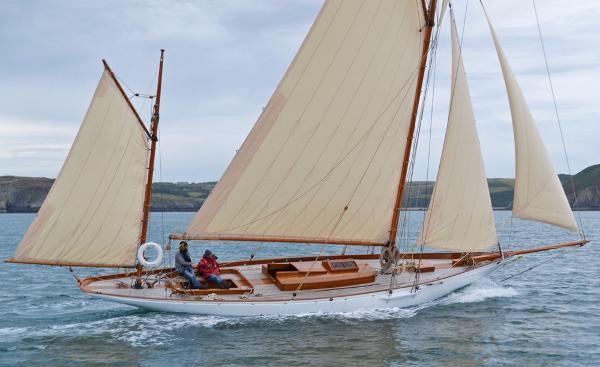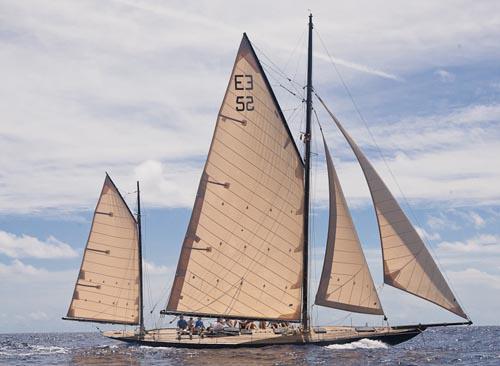The first image is the image on the left, the second image is the image on the right. Examine the images to the left and right. Is the description "All sailboats have at least four sails." accurate? Answer yes or no. Yes. The first image is the image on the left, the second image is the image on the right. Evaluate the accuracy of this statement regarding the images: "The boat on the right has more than three visible sails unfurled.". Is it true? Answer yes or no. Yes. 